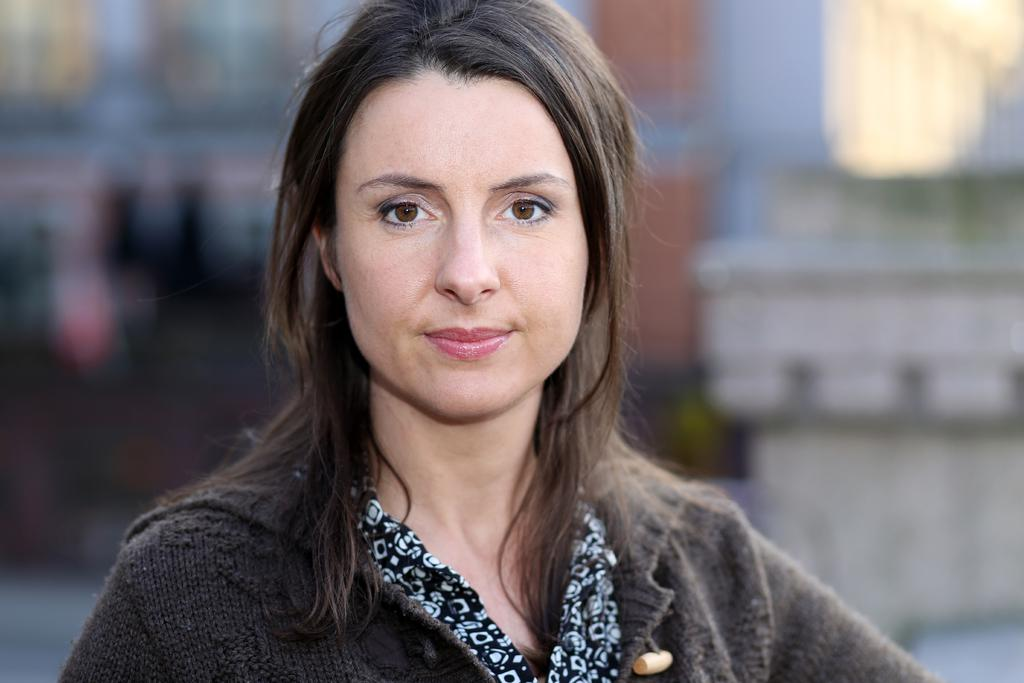Who is the main subject in the image? There is a woman in the image. What is the woman wearing? The woman is wearing a black and white dress. Can you describe the background of the image? The background of the image is blurry. What type of bottle is the woman holding in the image? There is no bottle present in the image; the woman is not holding anything. 